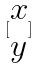Convert formula to latex. <formula><loc_0><loc_0><loc_500><loc_500>[ \begin{matrix} x \\ y \end{matrix} ]</formula> 